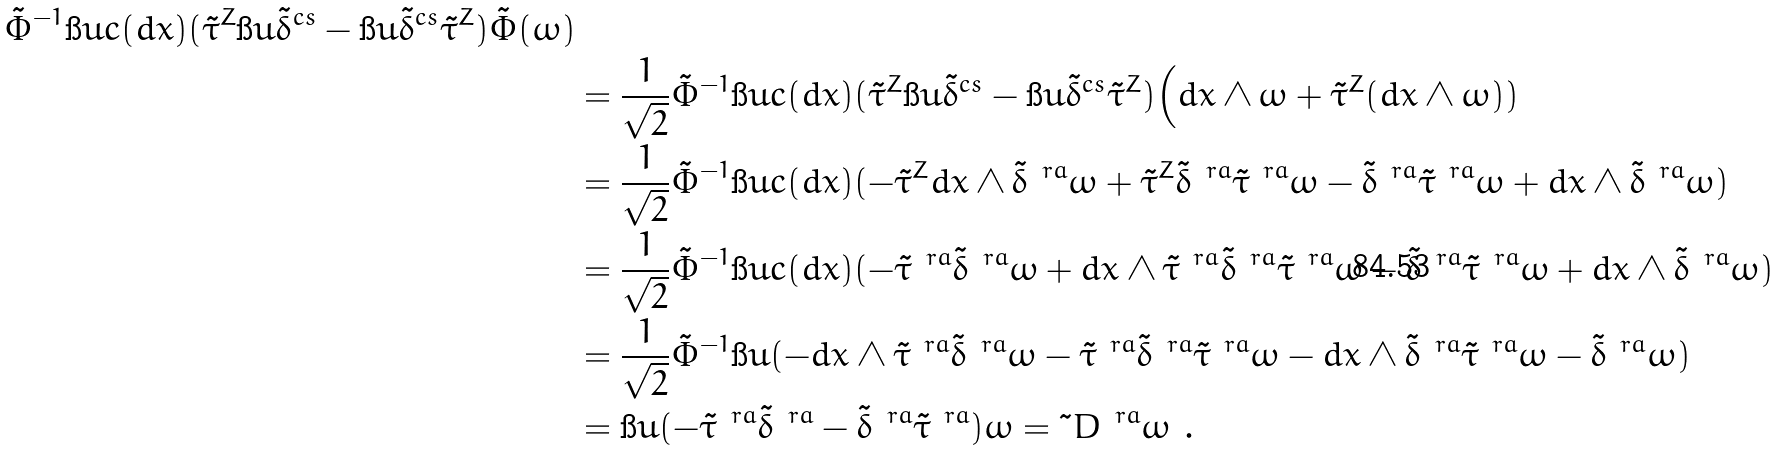<formula> <loc_0><loc_0><loc_500><loc_500>{ \tilde { \Phi } ^ { - 1 } \i u c ( d x ) ( \tilde { \tau } ^ { Z } \i u \tilde { \delta } ^ { c s } - \i u \tilde { \delta } ^ { c s } \tilde { \tau } ^ { Z } ) \tilde { \Phi } ( \omega ) } \\ & = \frac { 1 } { \sqrt { 2 } } \tilde { \Phi } ^ { - 1 } \i u c ( d x ) ( \tilde { \tau } ^ { Z } \i u \tilde { \delta } ^ { c s } - \i u \tilde { \delta } ^ { c s } \tilde { \tau } ^ { Z } ) \Big ( d x \wedge \omega + \tilde { \tau } ^ { Z } ( d x \wedge \omega ) ) \\ & = \frac { 1 } { \sqrt { 2 } } \tilde { \Phi } ^ { - 1 } \i u c ( d x ) ( - \tilde { \tau } ^ { Z } d x \wedge \tilde { \delta } ^ { \ r a } \omega + \tilde { \tau } ^ { Z } \tilde { \delta } ^ { \ r a } \tilde { \tau } ^ { \ r a } \omega - \tilde { \delta } ^ { \ r a } \tilde { \tau } ^ { \ r a } \omega + d x \wedge \tilde { \delta } ^ { \ r a } \omega ) \\ & = \frac { 1 } { \sqrt { 2 } } \tilde { \Phi } ^ { - 1 } \i u c ( d x ) ( - \tilde { \tau } ^ { \ r a } \tilde { \delta } ^ { \ r a } \omega + d x \wedge \tilde { \tau } ^ { \ r a } \tilde { \delta } ^ { \ r a } \tilde { \tau } ^ { \ r a } \omega - \tilde { \delta } ^ { \ r a } \tilde { \tau } ^ { \ r a } \omega + d x \wedge \tilde { \delta } ^ { \ r a } \omega ) \\ & = \frac { 1 } { \sqrt { 2 } } \tilde { \Phi } ^ { - 1 } \i u ( - d x \wedge \tilde { \tau } ^ { \ r a } \tilde { \delta } ^ { \ r a } \omega - \tilde { \tau } ^ { \ r a } \tilde { \delta } ^ { \ r a } \tilde { \tau } ^ { \ r a } \omega - d x \wedge \tilde { \delta } ^ { \ r a } \tilde { \tau } ^ { \ r a } \omega - \tilde { \delta } ^ { \ r a } \omega ) \\ & = \i u ( - \tilde { \tau } ^ { \ r a } \tilde { \delta } ^ { \ r a } - \tilde { \delta } ^ { \ r a } \tilde { \tau } ^ { \ r a } ) \omega = \tilde { \ } D ^ { \ r a } \omega \ .</formula> 